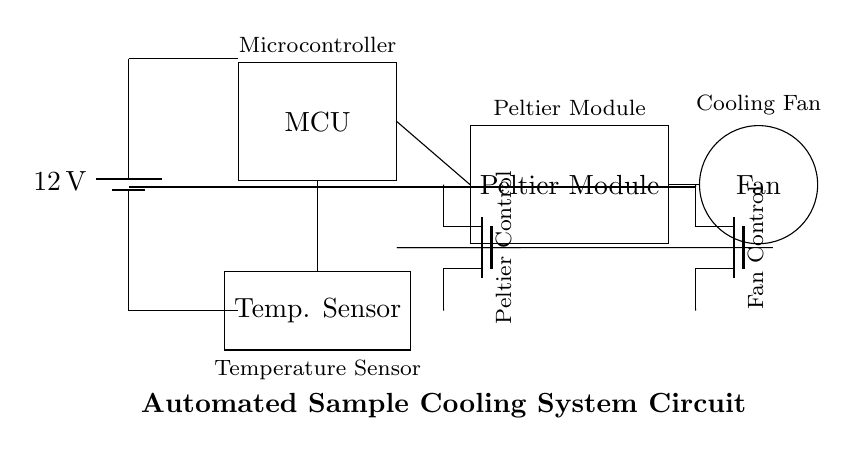What is the voltage of this circuit? The circuit diagram indicates a battery supplying 12 volts, which is labeled in the circuit.
Answer: 12 volts What is the function of the temperature sensor? The temperature sensor measures the temperature and sends the data to the microcontroller for monitoring and control of the cooling system.
Answer: Monitoring temperature What type of components are the Peltier and fan controlled by? Both the Peltier module and the fan are controlled by MOSFET transistors, which serve as switches for enabling or disabling them based on microcontroller signals.
Answer: MOSFET transistors How many control signals are sent from the microcontroller? The microcontroller sends two control signals, one for the Peltier module and one for the cooling fan, allowing it to manage both components independently.
Answer: Two What is the role of the microcontroller in this circuit? The microcontroller processes the input from the temperature sensor and controls the operation of the Peltier module and fan based on temperature readings to maintain the required sample cooling conditions.
Answer: Control operation What happens if the temperature exceeds a certain threshold? If the temperature exceeds a specific threshold, the microcontroller activates the Peltier module to cool the samples and may also turn on the fan to assist in heat dissipation.
Answer: Cooling activation 